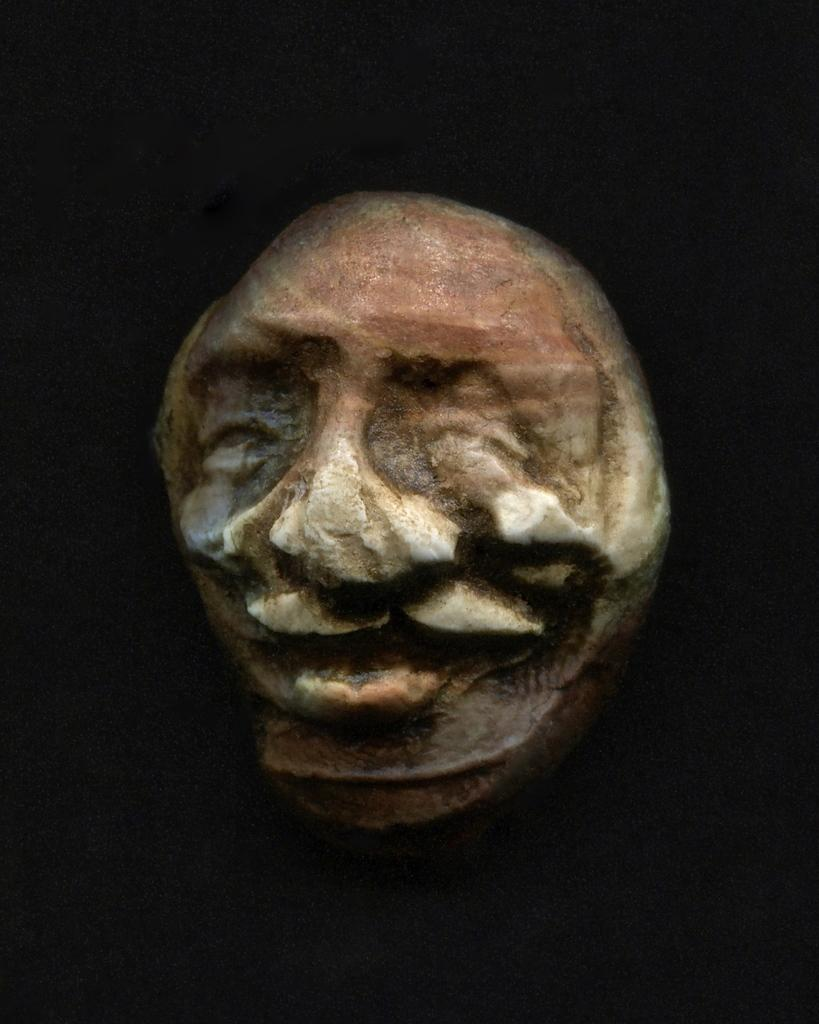What is the main subject of the image? There is a sculpture of a person's face in the image. What can be seen in the background of the image? The background of the image is dark. How many sisters are depicted in the sculpture? There are no sisters depicted in the sculpture; it is a sculpture of a single person's face. What type of clam is used as a base for the sculpture? There is no clam present in the image; it is a sculpture of a person's face made from an unspecified material. 